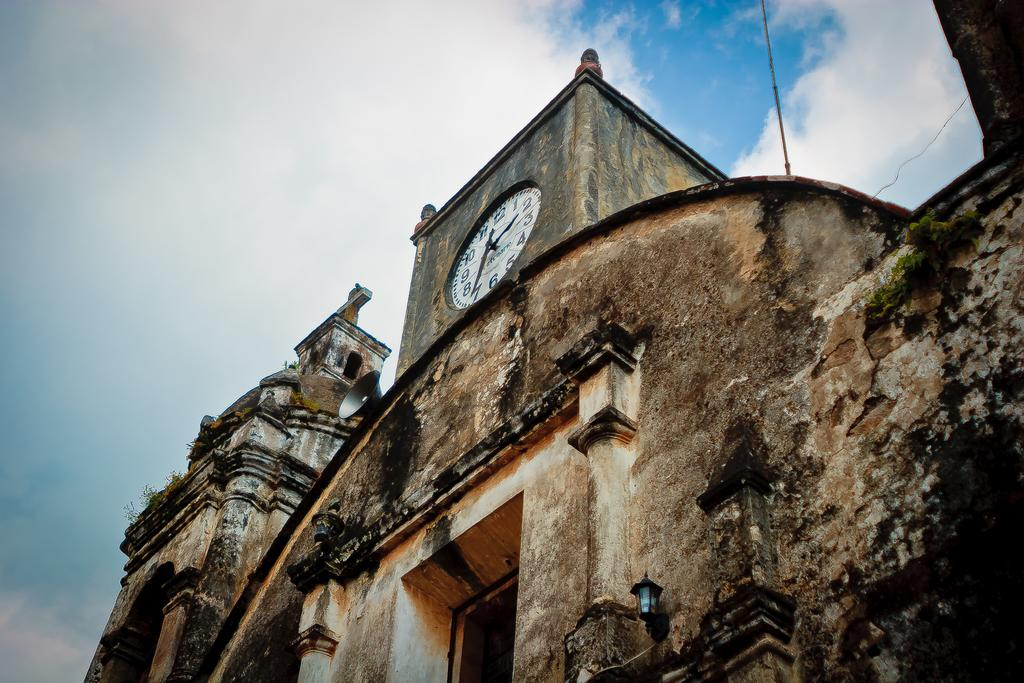What type of structure is the main subject of the image? There is a clock tower in the image. What is located at the bottom of the image? There is a door at the bottom of the image. What other notable structure can be seen in the image? There is a monument in the image. What is visible at the top of the image? The sky is visible at the top of the image. What can be observed in the sky? Clouds are present in the sky. How many girls are leading the monument in the image? There are no girls present in the image, nor is there any indication of a leadership role. 